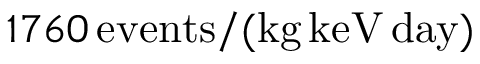Convert formula to latex. <formula><loc_0><loc_0><loc_500><loc_500>1 7 6 0 \, e v e n t s / ( k g \, k e V \, d a y )</formula> 